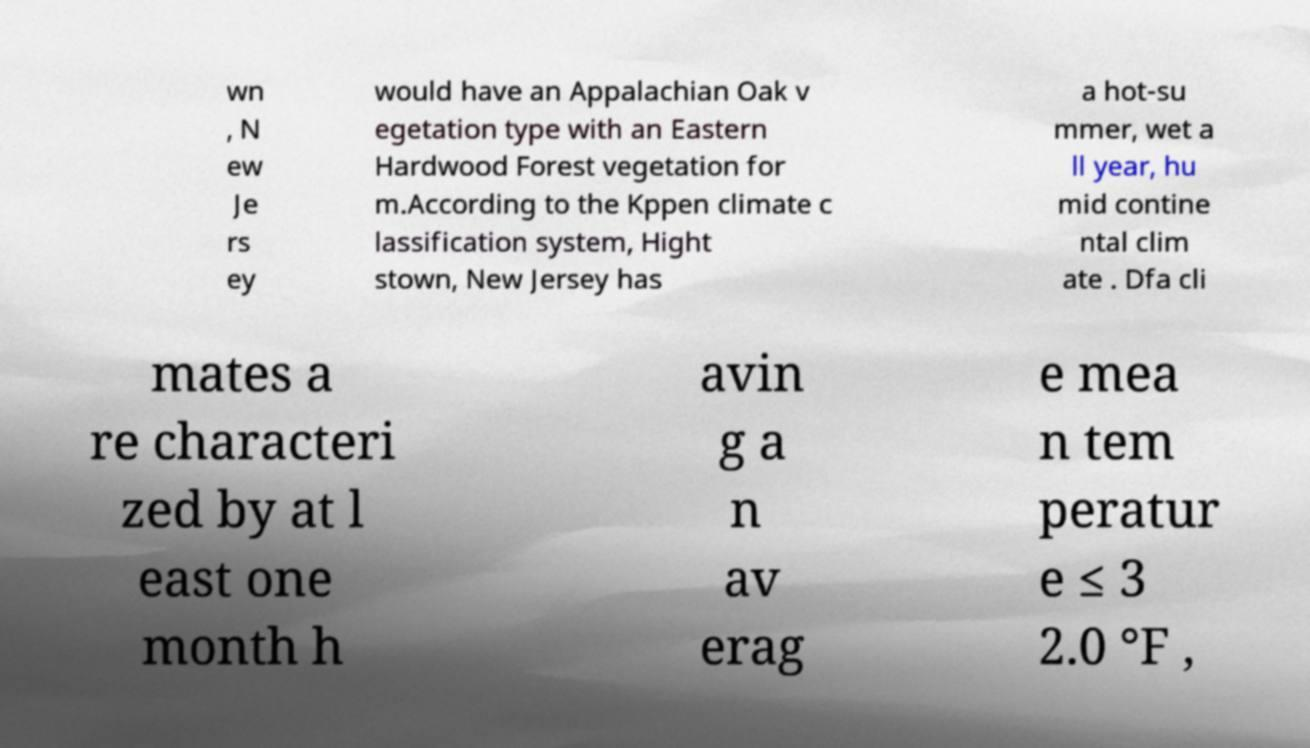Please identify and transcribe the text found in this image. wn , N ew Je rs ey would have an Appalachian Oak v egetation type with an Eastern Hardwood Forest vegetation for m.According to the Kppen climate c lassification system, Hight stown, New Jersey has a hot-su mmer, wet a ll year, hu mid contine ntal clim ate . Dfa cli mates a re characteri zed by at l east one month h avin g a n av erag e mea n tem peratur e ≤ 3 2.0 °F , 